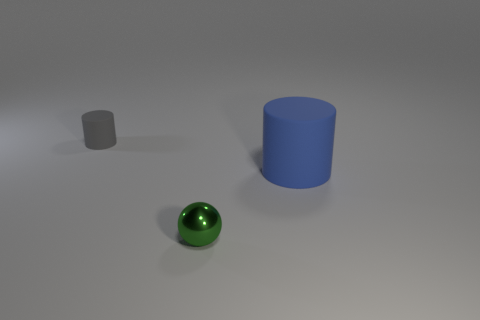Add 3 gray things. How many objects exist? 6 Subtract all balls. How many objects are left? 2 Subtract 0 cyan cubes. How many objects are left? 3 Subtract all small cyan cubes. Subtract all spheres. How many objects are left? 2 Add 1 spheres. How many spheres are left? 2 Add 3 big yellow rubber spheres. How many big yellow rubber spheres exist? 3 